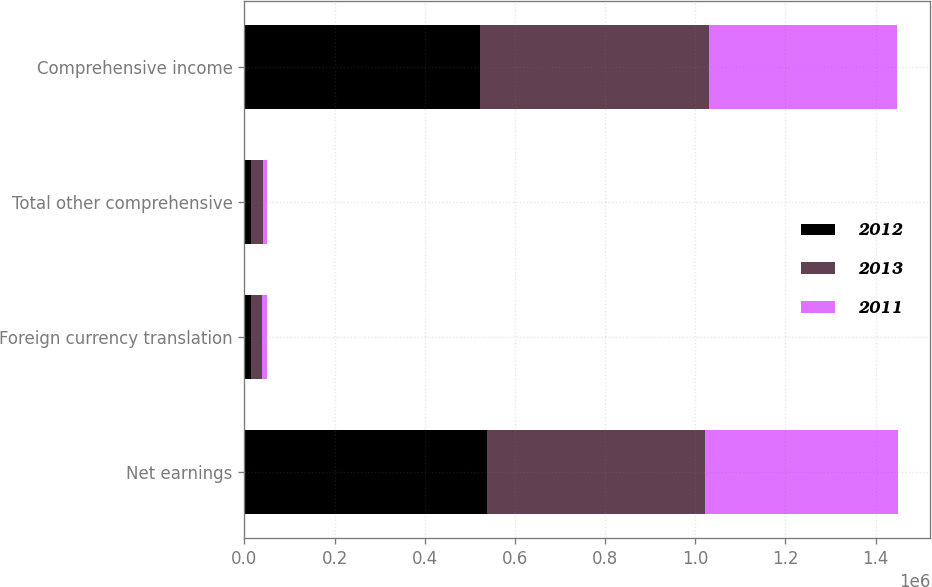Convert chart to OTSL. <chart><loc_0><loc_0><loc_500><loc_500><stacked_bar_chart><ecel><fcel>Net earnings<fcel>Foreign currency translation<fcel>Total other comprehensive<fcel>Comprehensive income<nl><fcel>2012<fcel>538293<fcel>15454<fcel>15454<fcel>522839<nl><fcel>2013<fcel>483360<fcel>23633<fcel>24737<fcel>508097<nl><fcel>2011<fcel>427247<fcel>10178<fcel>10178<fcel>417069<nl></chart> 